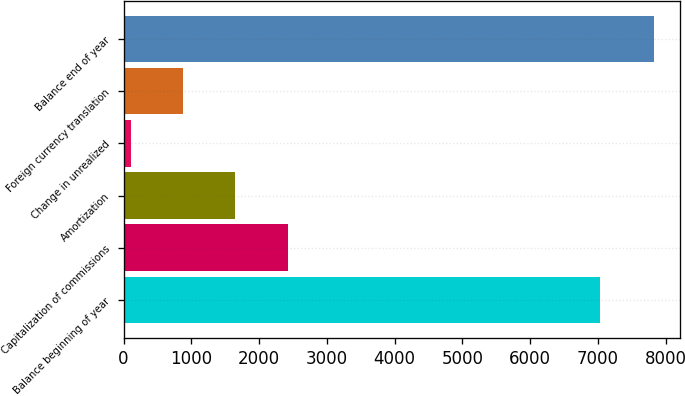<chart> <loc_0><loc_0><loc_500><loc_500><bar_chart><fcel>Balance beginning of year<fcel>Capitalization of commissions<fcel>Amortization<fcel>Change in unrealized<fcel>Foreign currency translation<fcel>Balance end of year<nl><fcel>7031<fcel>2419.9<fcel>1647.6<fcel>103<fcel>875.3<fcel>7826<nl></chart> 